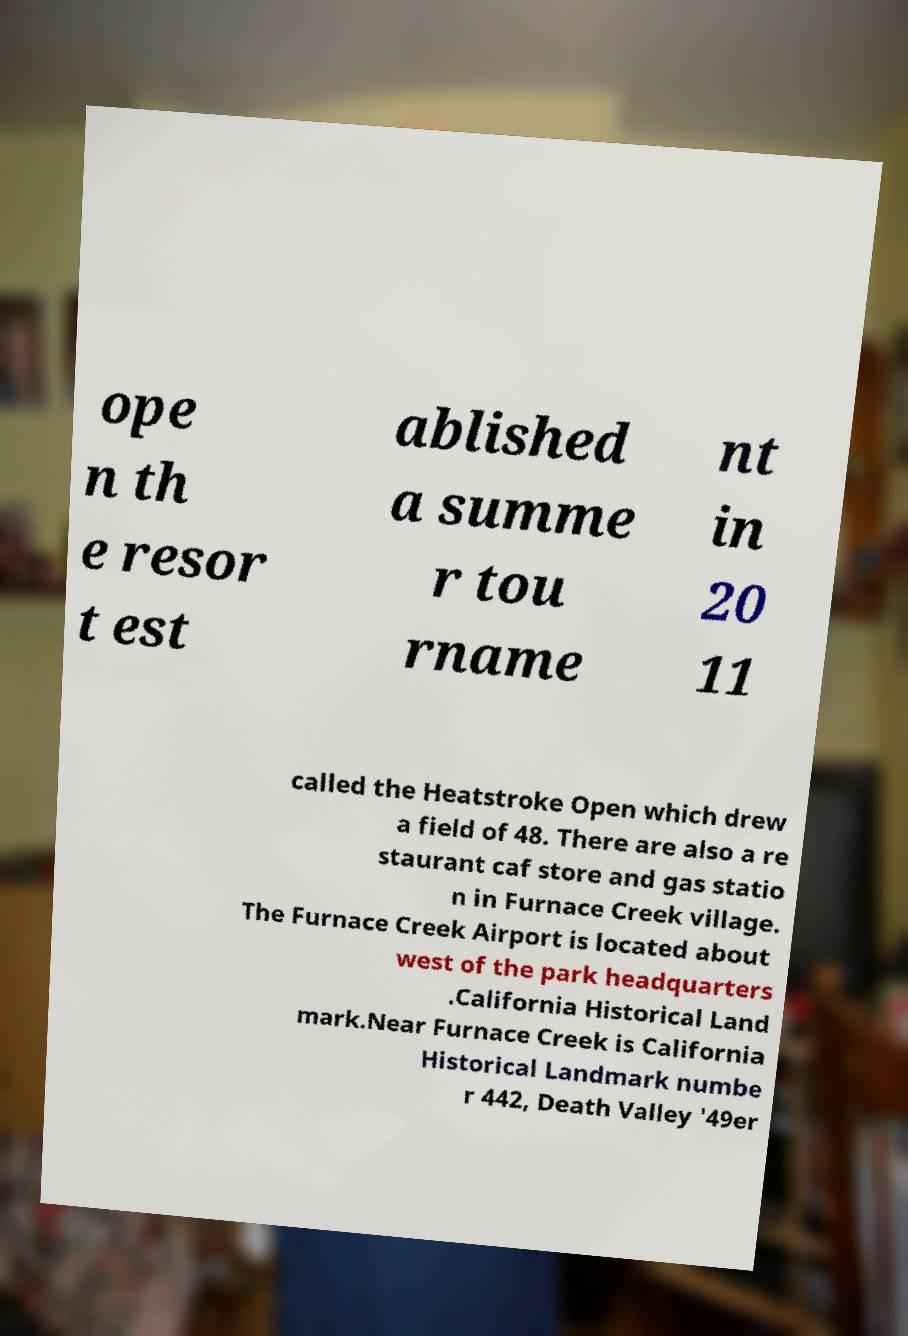Can you accurately transcribe the text from the provided image for me? ope n th e resor t est ablished a summe r tou rname nt in 20 11 called the Heatstroke Open which drew a field of 48. There are also a re staurant caf store and gas statio n in Furnace Creek village. The Furnace Creek Airport is located about west of the park headquarters .California Historical Land mark.Near Furnace Creek is California Historical Landmark numbe r 442, Death Valley '49er 